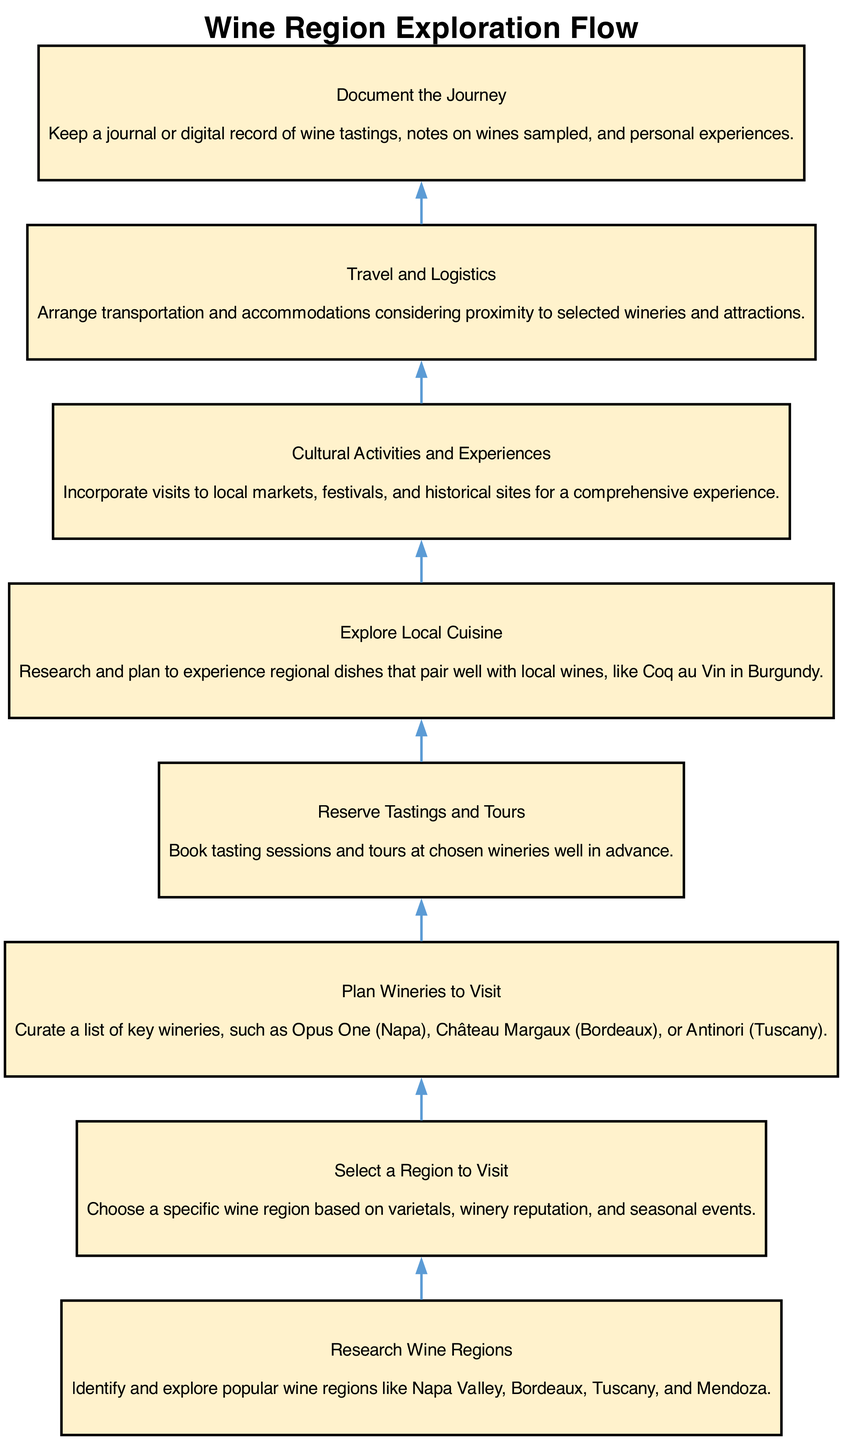What is the first step in the flow chart? The first step listed in the diagram is "Research Wine Regions," which indicates the starting point for the exploration sequence.
Answer: Research Wine Regions How many nodes are in the diagram? There are eight nodes in total, each representing a different step in the wine region exploration process as depicted in the diagram.
Answer: 8 What comes after "Select a Region to Visit"? After "Select a Region to Visit," the next step is "Plan Wineries to Visit," which follows directly in the sequence outlined by the flowchart.
Answer: Plan Wineries to Visit What is the last step in the process? The last step in the diagram is "Document the Journey," indicating that recording experiences is the final action in the exploration flow.
Answer: Document the Journey What relationship exists between "Explore Local Cuisine" and "Cultural Activities and Experiences"? "Explore Local Cuisine" and "Cultural Activities and Experiences" are parallel steps in the flow, both contributing to a holistic experience during the visit to the wine region.
Answer: Parallel relationship What are you expected to do in "Reserve Tastings and Tours"? In "Reserve Tastings and Tours," you are expected to book your tasting sessions and tours at the selected wineries ahead of time to ensure a spot.
Answer: Book tasting sessions and tours In which step do you arrange transportation? Transportation arrangements are made in the step "Travel and Logistics," which addresses the organization of travel details.
Answer: Travel and Logistics How do "Research Wine Regions" and "Select a Region to Visit" relate? "Research Wine Regions" serves as the foundation for "Select a Region to Visit," as selecting a region is based on the research conducted in the prior step.
Answer: Foundation relationship 